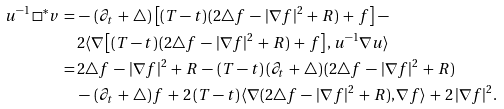Convert formula to latex. <formula><loc_0><loc_0><loc_500><loc_500>u ^ { - 1 } \, \square ^ { * } v \, = \, & - \, ( \partial _ { t } \, + \, \triangle ) \, \left [ ( T - t ) \, ( 2 \triangle f \, - \, | \nabla f | ^ { 2 } \, + \, R ) \, + \, f \right ] \, - \\ & 2 \langle \nabla \left [ ( T - t ) \, ( 2 \triangle f \, - \, | \nabla f | ^ { 2 } \, + \, R ) \, + \, f \right ] , u ^ { - 1 } \nabla u \rangle \\ \, = \, & 2 \triangle f \, - \, | \nabla f | ^ { 2 } \, + \, R \, - \, ( T - t ) \, ( \partial _ { t } \, + \, \triangle ) \, ( 2 \triangle f \, - \, | \nabla f | ^ { 2 } \, + \, R ) \\ & - \, ( \partial _ { t } \, + \, \triangle ) \, f \, + \, 2 \, ( T - t ) \, \langle \nabla ( 2 \triangle f \, - \, | \nabla f | ^ { 2 } \, + \, R ) , \nabla f \rangle \, + \, 2 \, | \nabla f | ^ { 2 } .</formula> 